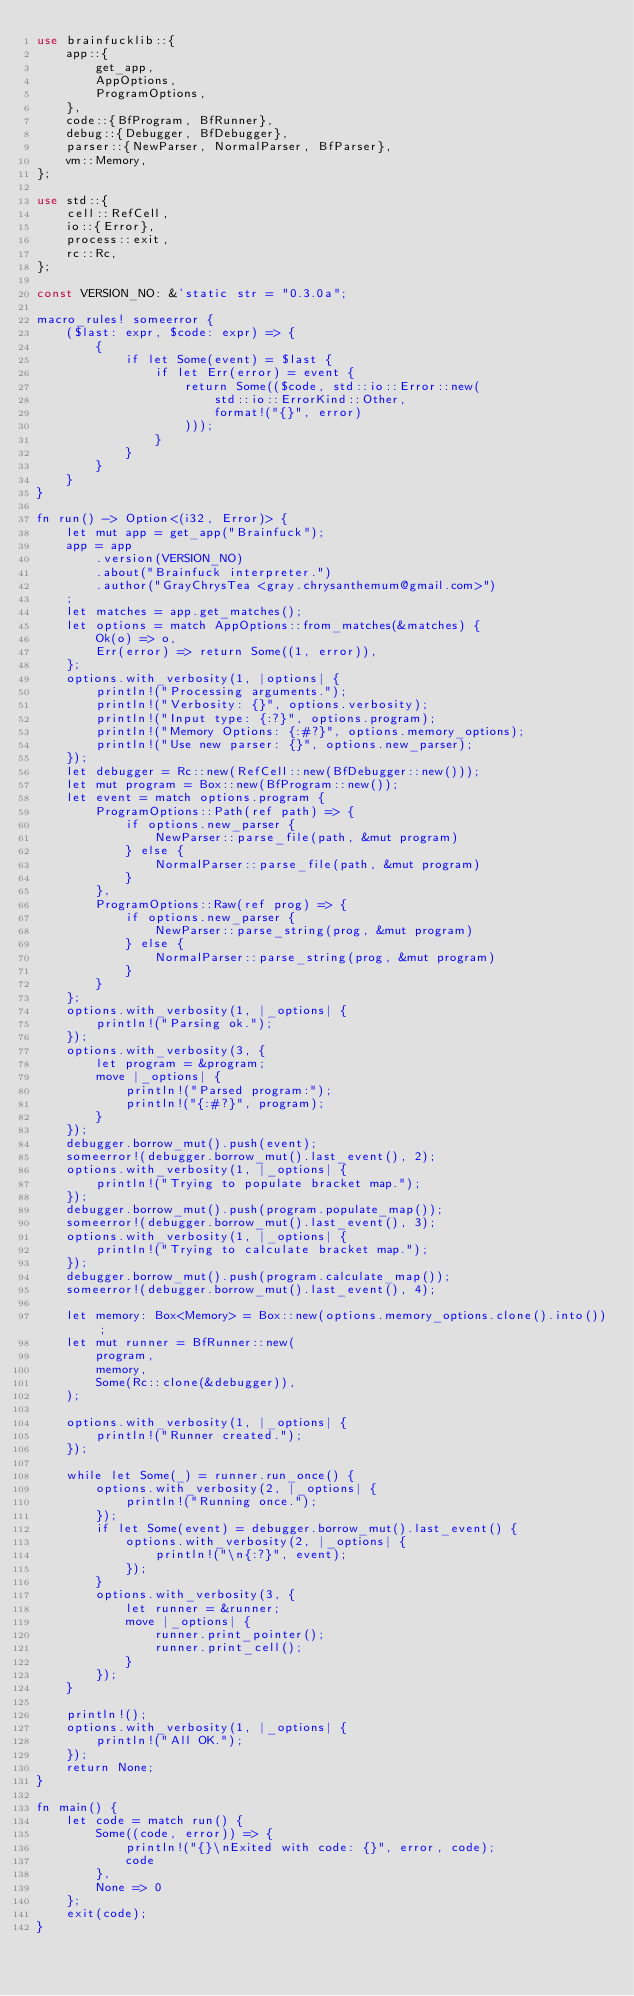<code> <loc_0><loc_0><loc_500><loc_500><_Rust_>use brainfucklib::{
    app::{
        get_app,
        AppOptions,
        ProgramOptions,
    },
    code::{BfProgram, BfRunner},
    debug::{Debugger, BfDebugger},
    parser::{NewParser, NormalParser, BfParser},
    vm::Memory,
};

use std::{
    cell::RefCell,
    io::{Error},
    process::exit,
    rc::Rc,
};

const VERSION_NO: &'static str = "0.3.0a";

macro_rules! someerror {
    ($last: expr, $code: expr) => {
        {
            if let Some(event) = $last {
                if let Err(error) = event {
                    return Some(($code, std::io::Error::new(
                        std::io::ErrorKind::Other,
                        format!("{}", error)
                    )));
                }
            }
        }
    }
}

fn run() -> Option<(i32, Error)> {
    let mut app = get_app("Brainfuck");
    app = app
        .version(VERSION_NO)
        .about("Brainfuck interpreter.")
        .author("GrayChrysTea <gray.chrysanthemum@gmail.com>")
    ;
    let matches = app.get_matches();
    let options = match AppOptions::from_matches(&matches) {
        Ok(o) => o,
        Err(error) => return Some((1, error)),
    };
    options.with_verbosity(1, |options| {
        println!("Processing arguments.");
        println!("Verbosity: {}", options.verbosity);
        println!("Input type: {:?}", options.program);
        println!("Memory Options: {:#?}", options.memory_options);
        println!("Use new parser: {}", options.new_parser);
    });
    let debugger = Rc::new(RefCell::new(BfDebugger::new()));
    let mut program = Box::new(BfProgram::new());
    let event = match options.program {
        ProgramOptions::Path(ref path) => {
            if options.new_parser {
                NewParser::parse_file(path, &mut program)
            } else {
                NormalParser::parse_file(path, &mut program)
            }
        },
        ProgramOptions::Raw(ref prog) => {
            if options.new_parser {
                NewParser::parse_string(prog, &mut program)
            } else {
                NormalParser::parse_string(prog, &mut program)
            }
        }
    };
    options.with_verbosity(1, |_options| {
        println!("Parsing ok.");
    });
    options.with_verbosity(3, {
        let program = &program;
        move |_options| {
            println!("Parsed program:");
            println!("{:#?}", program);
        }
    });
    debugger.borrow_mut().push(event);
    someerror!(debugger.borrow_mut().last_event(), 2);
    options.with_verbosity(1, |_options| {
        println!("Trying to populate bracket map.");
    });
    debugger.borrow_mut().push(program.populate_map());
    someerror!(debugger.borrow_mut().last_event(), 3);
    options.with_verbosity(1, |_options| {
        println!("Trying to calculate bracket map.");
    });
    debugger.borrow_mut().push(program.calculate_map());
    someerror!(debugger.borrow_mut().last_event(), 4);

    let memory: Box<Memory> = Box::new(options.memory_options.clone().into());
    let mut runner = BfRunner::new(
        program,
        memory,
        Some(Rc::clone(&debugger)),
    );

    options.with_verbosity(1, |_options| {
        println!("Runner created.");
    });

    while let Some(_) = runner.run_once() {
        options.with_verbosity(2, |_options| {
            println!("Running once.");
        });
        if let Some(event) = debugger.borrow_mut().last_event() {
            options.with_verbosity(2, |_options| {
                println!("\n{:?}", event);
            });
        }
        options.with_verbosity(3, {
            let runner = &runner;
            move |_options| {
                runner.print_pointer();
                runner.print_cell();
            }
        });
    }

    println!();
    options.with_verbosity(1, |_options| {
        println!("All OK.");
    });
    return None;
}

fn main() {
    let code = match run() {
        Some((code, error)) => {
            println!("{}\nExited with code: {}", error, code);
            code
        },
        None => 0
    };
    exit(code);
}</code> 